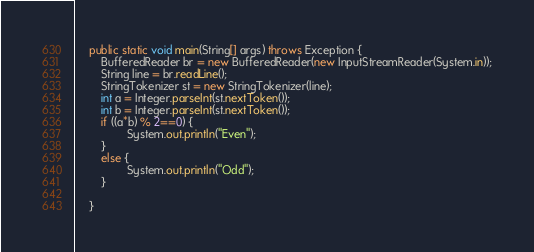<code> <loc_0><loc_0><loc_500><loc_500><_Java_>	public static void main(String[] args) throws Exception {
		BufferedReader br = new BufferedReader(new InputStreamReader(System.in));
	    String line = br.readLine();
	    StringTokenizer st = new StringTokenizer(line);
	    int a = Integer.parseInt(st.nextToken());
	    int b = Integer.parseInt(st.nextToken());
	    if ((a*b) % 2==0) {
	    		System.out.println("Even");
	    }
	    else {
	    		System.out.println("Odd");
	    }

	}</code> 